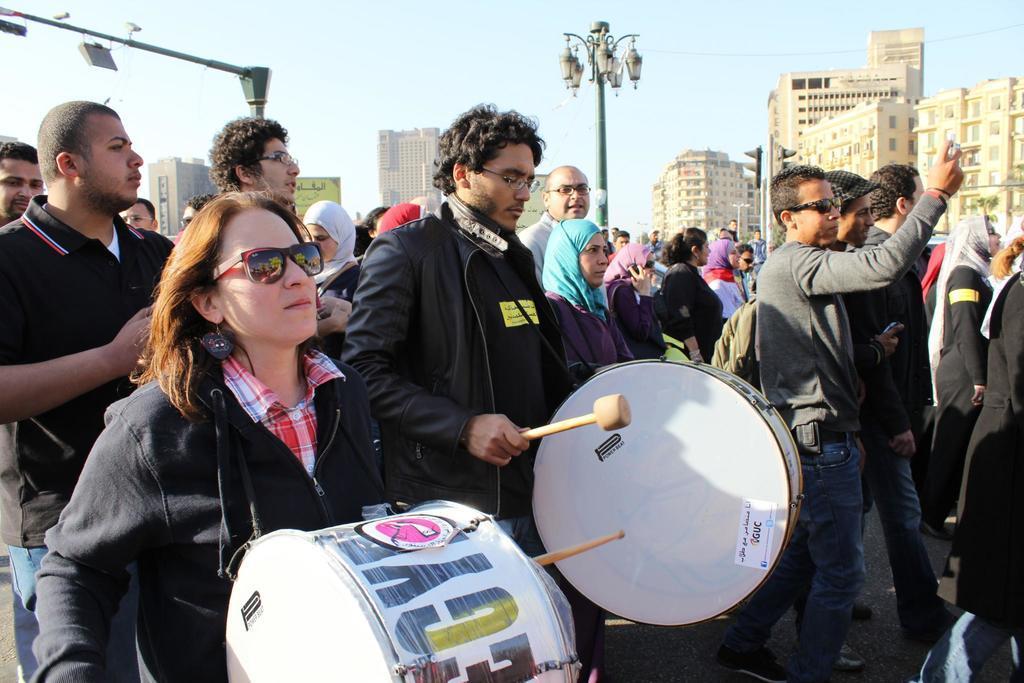In one or two sentences, can you explain what this image depicts? In this image I can see group of people walking. I can see two persons playing drums. In the background I can see buildings. 